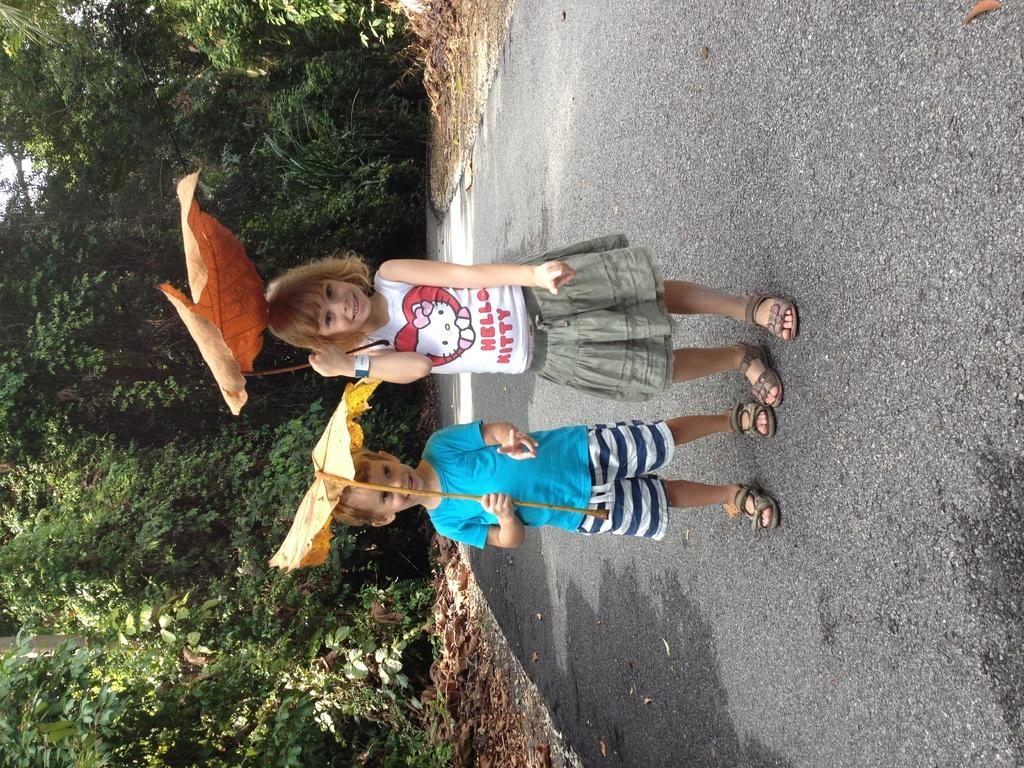<image>
Offer a succinct explanation of the picture presented. Two children posing for a photo with the girl wearing a shirt that says HELLO KITTY. 